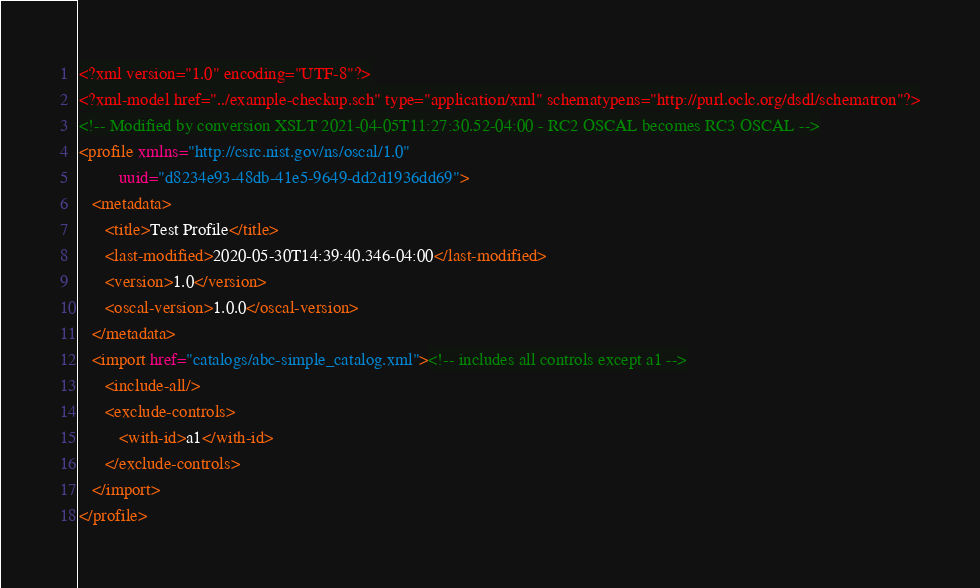<code> <loc_0><loc_0><loc_500><loc_500><_XML_><?xml version="1.0" encoding="UTF-8"?>
<?xml-model href="../example-checkup.sch" type="application/xml" schematypens="http://purl.oclc.org/dsdl/schematron"?>
<!-- Modified by conversion XSLT 2021-04-05T11:27:30.52-04:00 - RC2 OSCAL becomes RC3 OSCAL -->
<profile xmlns="http://csrc.nist.gov/ns/oscal/1.0"
         uuid="d8234e93-48db-41e5-9649-dd2d1936dd69">
   <metadata>
      <title>Test Profile</title>
      <last-modified>2020-05-30T14:39:40.346-04:00</last-modified>
      <version>1.0</version>
      <oscal-version>1.0.0</oscal-version>
   </metadata>
   <import href="catalogs/abc-simple_catalog.xml"><!-- includes all controls except a1 -->
      <include-all/>
      <exclude-controls>
         <with-id>a1</with-id>
      </exclude-controls>
   </import>
</profile>
</code> 